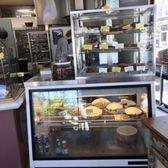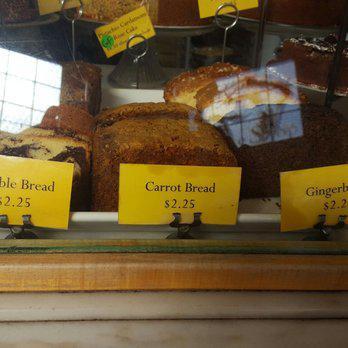The first image is the image on the left, the second image is the image on the right. For the images displayed, is the sentence "Pastries have yellow labels in one of the images." factually correct? Answer yes or no. Yes. The first image is the image on the left, the second image is the image on the right. Examine the images to the left and right. Is the description "There are a multiple baked goods per image, exposed to open air." accurate? Answer yes or no. No. 